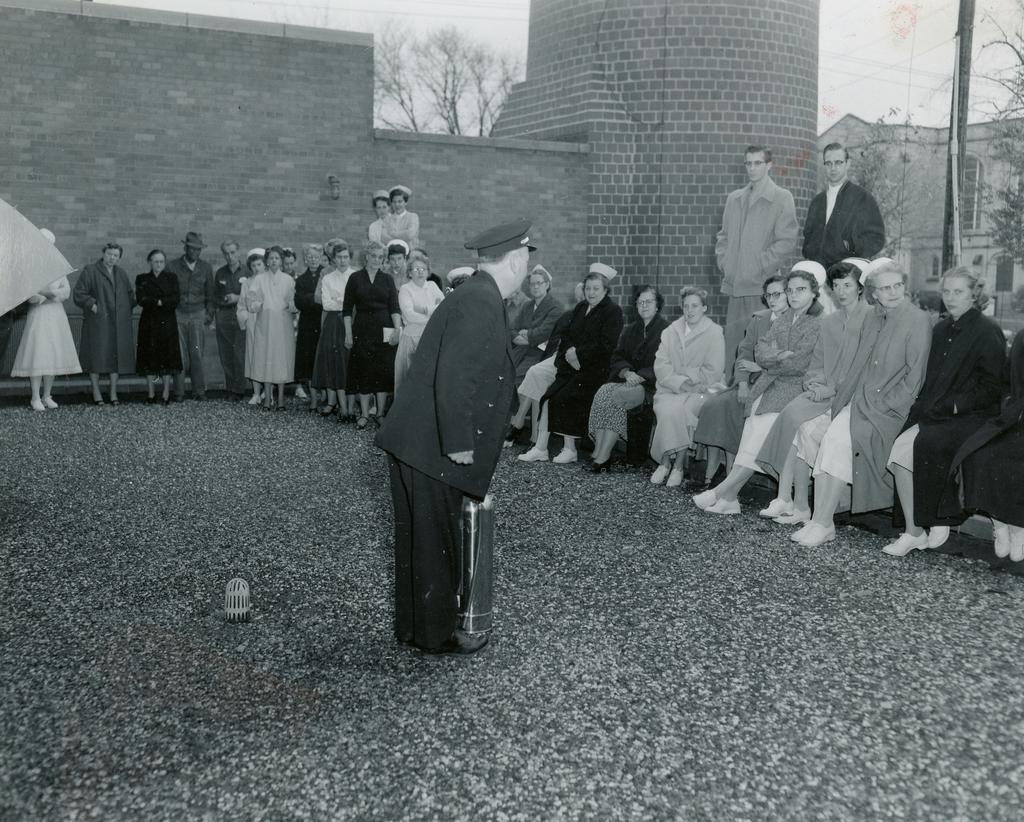What are the people in the image doing? There are people standing and sitting in the image. What type of structures can be seen in the image? There are buildings in the image. What architectural features are visible on the buildings? There are windows visible on the buildings. What type of vegetation is present in the image? There are trees in the image. What is the purpose of the pole in the image? The purpose of the pole is not specified, but it is present in the image. What can be seen in the sky in the image? The sky is visible in the image. What is the color scheme of the image? The image is in black and white. Can you tell me how many farmers are milking cows in the image? There are no farmers or cows present in the image. What type of carriage is being pulled by horses in the image? There is no carriage or horses present in the image. 